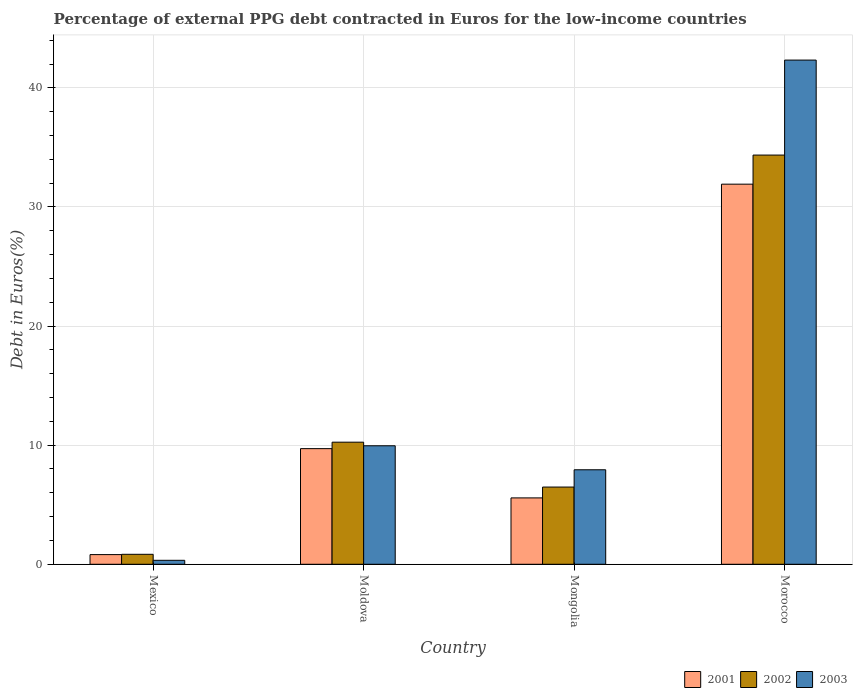How many different coloured bars are there?
Offer a very short reply. 3. Are the number of bars per tick equal to the number of legend labels?
Your answer should be very brief. Yes. How many bars are there on the 4th tick from the right?
Your answer should be very brief. 3. In how many cases, is the number of bars for a given country not equal to the number of legend labels?
Provide a short and direct response. 0. What is the percentage of external PPG debt contracted in Euros in 2002 in Mongolia?
Offer a very short reply. 6.48. Across all countries, what is the maximum percentage of external PPG debt contracted in Euros in 2003?
Provide a short and direct response. 42.33. Across all countries, what is the minimum percentage of external PPG debt contracted in Euros in 2001?
Offer a very short reply. 0.81. In which country was the percentage of external PPG debt contracted in Euros in 2001 maximum?
Offer a very short reply. Morocco. What is the total percentage of external PPG debt contracted in Euros in 2003 in the graph?
Make the answer very short. 60.55. What is the difference between the percentage of external PPG debt contracted in Euros in 2002 in Mexico and that in Mongolia?
Make the answer very short. -5.65. What is the difference between the percentage of external PPG debt contracted in Euros in 2001 in Mexico and the percentage of external PPG debt contracted in Euros in 2002 in Moldova?
Offer a very short reply. -9.44. What is the average percentage of external PPG debt contracted in Euros in 2002 per country?
Provide a short and direct response. 12.98. What is the difference between the percentage of external PPG debt contracted in Euros of/in 2001 and percentage of external PPG debt contracted in Euros of/in 2003 in Moldova?
Give a very brief answer. -0.24. What is the ratio of the percentage of external PPG debt contracted in Euros in 2001 in Mexico to that in Mongolia?
Your response must be concise. 0.15. Is the percentage of external PPG debt contracted in Euros in 2002 in Moldova less than that in Mongolia?
Your answer should be compact. No. Is the difference between the percentage of external PPG debt contracted in Euros in 2001 in Moldova and Mongolia greater than the difference between the percentage of external PPG debt contracted in Euros in 2003 in Moldova and Mongolia?
Your answer should be compact. Yes. What is the difference between the highest and the second highest percentage of external PPG debt contracted in Euros in 2001?
Provide a short and direct response. 4.14. What is the difference between the highest and the lowest percentage of external PPG debt contracted in Euros in 2001?
Give a very brief answer. 31.1. Is the sum of the percentage of external PPG debt contracted in Euros in 2003 in Moldova and Mongolia greater than the maximum percentage of external PPG debt contracted in Euros in 2001 across all countries?
Make the answer very short. No. What does the 2nd bar from the left in Mongolia represents?
Your answer should be very brief. 2002. Is it the case that in every country, the sum of the percentage of external PPG debt contracted in Euros in 2002 and percentage of external PPG debt contracted in Euros in 2003 is greater than the percentage of external PPG debt contracted in Euros in 2001?
Offer a very short reply. Yes. Are all the bars in the graph horizontal?
Give a very brief answer. No. Are the values on the major ticks of Y-axis written in scientific E-notation?
Offer a terse response. No. Does the graph contain any zero values?
Give a very brief answer. No. Does the graph contain grids?
Your answer should be compact. Yes. Where does the legend appear in the graph?
Your answer should be very brief. Bottom right. How many legend labels are there?
Ensure brevity in your answer.  3. What is the title of the graph?
Your answer should be compact. Percentage of external PPG debt contracted in Euros for the low-income countries. Does "1998" appear as one of the legend labels in the graph?
Ensure brevity in your answer.  No. What is the label or title of the Y-axis?
Ensure brevity in your answer.  Debt in Euros(%). What is the Debt in Euros(%) in 2001 in Mexico?
Keep it short and to the point. 0.81. What is the Debt in Euros(%) of 2002 in Mexico?
Keep it short and to the point. 0.84. What is the Debt in Euros(%) in 2003 in Mexico?
Keep it short and to the point. 0.33. What is the Debt in Euros(%) in 2001 in Moldova?
Provide a succinct answer. 9.71. What is the Debt in Euros(%) in 2002 in Moldova?
Offer a very short reply. 10.25. What is the Debt in Euros(%) of 2003 in Moldova?
Provide a short and direct response. 9.95. What is the Debt in Euros(%) of 2001 in Mongolia?
Your response must be concise. 5.57. What is the Debt in Euros(%) of 2002 in Mongolia?
Give a very brief answer. 6.48. What is the Debt in Euros(%) of 2003 in Mongolia?
Your response must be concise. 7.93. What is the Debt in Euros(%) in 2001 in Morocco?
Your answer should be very brief. 31.91. What is the Debt in Euros(%) of 2002 in Morocco?
Make the answer very short. 34.36. What is the Debt in Euros(%) of 2003 in Morocco?
Give a very brief answer. 42.33. Across all countries, what is the maximum Debt in Euros(%) of 2001?
Your answer should be very brief. 31.91. Across all countries, what is the maximum Debt in Euros(%) in 2002?
Your response must be concise. 34.36. Across all countries, what is the maximum Debt in Euros(%) in 2003?
Ensure brevity in your answer.  42.33. Across all countries, what is the minimum Debt in Euros(%) of 2001?
Ensure brevity in your answer.  0.81. Across all countries, what is the minimum Debt in Euros(%) in 2002?
Ensure brevity in your answer.  0.84. Across all countries, what is the minimum Debt in Euros(%) of 2003?
Provide a short and direct response. 0.33. What is the total Debt in Euros(%) in 2001 in the graph?
Ensure brevity in your answer.  48.01. What is the total Debt in Euros(%) of 2002 in the graph?
Your response must be concise. 51.93. What is the total Debt in Euros(%) of 2003 in the graph?
Ensure brevity in your answer.  60.55. What is the difference between the Debt in Euros(%) in 2001 in Mexico and that in Moldova?
Offer a very short reply. -8.9. What is the difference between the Debt in Euros(%) in 2002 in Mexico and that in Moldova?
Your response must be concise. -9.41. What is the difference between the Debt in Euros(%) of 2003 in Mexico and that in Moldova?
Your answer should be compact. -9.62. What is the difference between the Debt in Euros(%) of 2001 in Mexico and that in Mongolia?
Make the answer very short. -4.76. What is the difference between the Debt in Euros(%) of 2002 in Mexico and that in Mongolia?
Offer a terse response. -5.65. What is the difference between the Debt in Euros(%) of 2003 in Mexico and that in Mongolia?
Your answer should be very brief. -7.6. What is the difference between the Debt in Euros(%) in 2001 in Mexico and that in Morocco?
Provide a succinct answer. -31.1. What is the difference between the Debt in Euros(%) in 2002 in Mexico and that in Morocco?
Provide a short and direct response. -33.52. What is the difference between the Debt in Euros(%) in 2003 in Mexico and that in Morocco?
Offer a terse response. -42. What is the difference between the Debt in Euros(%) in 2001 in Moldova and that in Mongolia?
Offer a terse response. 4.14. What is the difference between the Debt in Euros(%) of 2002 in Moldova and that in Mongolia?
Make the answer very short. 3.77. What is the difference between the Debt in Euros(%) of 2003 in Moldova and that in Mongolia?
Make the answer very short. 2.02. What is the difference between the Debt in Euros(%) in 2001 in Moldova and that in Morocco?
Your answer should be compact. -22.2. What is the difference between the Debt in Euros(%) of 2002 in Moldova and that in Morocco?
Offer a very short reply. -24.11. What is the difference between the Debt in Euros(%) in 2003 in Moldova and that in Morocco?
Provide a succinct answer. -32.38. What is the difference between the Debt in Euros(%) of 2001 in Mongolia and that in Morocco?
Make the answer very short. -26.34. What is the difference between the Debt in Euros(%) in 2002 in Mongolia and that in Morocco?
Provide a short and direct response. -27.87. What is the difference between the Debt in Euros(%) of 2003 in Mongolia and that in Morocco?
Give a very brief answer. -34.4. What is the difference between the Debt in Euros(%) in 2001 in Mexico and the Debt in Euros(%) in 2002 in Moldova?
Offer a terse response. -9.44. What is the difference between the Debt in Euros(%) in 2001 in Mexico and the Debt in Euros(%) in 2003 in Moldova?
Provide a succinct answer. -9.14. What is the difference between the Debt in Euros(%) of 2002 in Mexico and the Debt in Euros(%) of 2003 in Moldova?
Your answer should be compact. -9.11. What is the difference between the Debt in Euros(%) in 2001 in Mexico and the Debt in Euros(%) in 2002 in Mongolia?
Offer a terse response. -5.67. What is the difference between the Debt in Euros(%) of 2001 in Mexico and the Debt in Euros(%) of 2003 in Mongolia?
Provide a short and direct response. -7.12. What is the difference between the Debt in Euros(%) of 2002 in Mexico and the Debt in Euros(%) of 2003 in Mongolia?
Provide a succinct answer. -7.1. What is the difference between the Debt in Euros(%) in 2001 in Mexico and the Debt in Euros(%) in 2002 in Morocco?
Offer a very short reply. -33.54. What is the difference between the Debt in Euros(%) in 2001 in Mexico and the Debt in Euros(%) in 2003 in Morocco?
Your answer should be compact. -41.52. What is the difference between the Debt in Euros(%) in 2002 in Mexico and the Debt in Euros(%) in 2003 in Morocco?
Your response must be concise. -41.49. What is the difference between the Debt in Euros(%) of 2001 in Moldova and the Debt in Euros(%) of 2002 in Mongolia?
Your answer should be very brief. 3.23. What is the difference between the Debt in Euros(%) in 2001 in Moldova and the Debt in Euros(%) in 2003 in Mongolia?
Your answer should be compact. 1.77. What is the difference between the Debt in Euros(%) of 2002 in Moldova and the Debt in Euros(%) of 2003 in Mongolia?
Ensure brevity in your answer.  2.32. What is the difference between the Debt in Euros(%) in 2001 in Moldova and the Debt in Euros(%) in 2002 in Morocco?
Your answer should be compact. -24.65. What is the difference between the Debt in Euros(%) in 2001 in Moldova and the Debt in Euros(%) in 2003 in Morocco?
Make the answer very short. -32.62. What is the difference between the Debt in Euros(%) of 2002 in Moldova and the Debt in Euros(%) of 2003 in Morocco?
Your response must be concise. -32.08. What is the difference between the Debt in Euros(%) of 2001 in Mongolia and the Debt in Euros(%) of 2002 in Morocco?
Provide a short and direct response. -28.78. What is the difference between the Debt in Euros(%) of 2001 in Mongolia and the Debt in Euros(%) of 2003 in Morocco?
Provide a short and direct response. -36.76. What is the difference between the Debt in Euros(%) of 2002 in Mongolia and the Debt in Euros(%) of 2003 in Morocco?
Keep it short and to the point. -35.85. What is the average Debt in Euros(%) of 2001 per country?
Offer a terse response. 12. What is the average Debt in Euros(%) of 2002 per country?
Your response must be concise. 12.98. What is the average Debt in Euros(%) of 2003 per country?
Make the answer very short. 15.14. What is the difference between the Debt in Euros(%) in 2001 and Debt in Euros(%) in 2002 in Mexico?
Provide a succinct answer. -0.03. What is the difference between the Debt in Euros(%) of 2001 and Debt in Euros(%) of 2003 in Mexico?
Keep it short and to the point. 0.48. What is the difference between the Debt in Euros(%) in 2002 and Debt in Euros(%) in 2003 in Mexico?
Your response must be concise. 0.5. What is the difference between the Debt in Euros(%) of 2001 and Debt in Euros(%) of 2002 in Moldova?
Your answer should be compact. -0.54. What is the difference between the Debt in Euros(%) in 2001 and Debt in Euros(%) in 2003 in Moldova?
Provide a succinct answer. -0.24. What is the difference between the Debt in Euros(%) in 2002 and Debt in Euros(%) in 2003 in Moldova?
Offer a terse response. 0.3. What is the difference between the Debt in Euros(%) in 2001 and Debt in Euros(%) in 2002 in Mongolia?
Keep it short and to the point. -0.91. What is the difference between the Debt in Euros(%) of 2001 and Debt in Euros(%) of 2003 in Mongolia?
Keep it short and to the point. -2.36. What is the difference between the Debt in Euros(%) in 2002 and Debt in Euros(%) in 2003 in Mongolia?
Provide a short and direct response. -1.45. What is the difference between the Debt in Euros(%) of 2001 and Debt in Euros(%) of 2002 in Morocco?
Provide a short and direct response. -2.44. What is the difference between the Debt in Euros(%) of 2001 and Debt in Euros(%) of 2003 in Morocco?
Your response must be concise. -10.42. What is the difference between the Debt in Euros(%) in 2002 and Debt in Euros(%) in 2003 in Morocco?
Give a very brief answer. -7.98. What is the ratio of the Debt in Euros(%) in 2001 in Mexico to that in Moldova?
Provide a short and direct response. 0.08. What is the ratio of the Debt in Euros(%) in 2002 in Mexico to that in Moldova?
Ensure brevity in your answer.  0.08. What is the ratio of the Debt in Euros(%) of 2003 in Mexico to that in Moldova?
Your response must be concise. 0.03. What is the ratio of the Debt in Euros(%) of 2001 in Mexico to that in Mongolia?
Your response must be concise. 0.15. What is the ratio of the Debt in Euros(%) in 2002 in Mexico to that in Mongolia?
Your answer should be compact. 0.13. What is the ratio of the Debt in Euros(%) in 2003 in Mexico to that in Mongolia?
Ensure brevity in your answer.  0.04. What is the ratio of the Debt in Euros(%) in 2001 in Mexico to that in Morocco?
Provide a succinct answer. 0.03. What is the ratio of the Debt in Euros(%) in 2002 in Mexico to that in Morocco?
Your response must be concise. 0.02. What is the ratio of the Debt in Euros(%) of 2003 in Mexico to that in Morocco?
Make the answer very short. 0.01. What is the ratio of the Debt in Euros(%) of 2001 in Moldova to that in Mongolia?
Provide a succinct answer. 1.74. What is the ratio of the Debt in Euros(%) in 2002 in Moldova to that in Mongolia?
Offer a very short reply. 1.58. What is the ratio of the Debt in Euros(%) of 2003 in Moldova to that in Mongolia?
Keep it short and to the point. 1.25. What is the ratio of the Debt in Euros(%) in 2001 in Moldova to that in Morocco?
Your answer should be very brief. 0.3. What is the ratio of the Debt in Euros(%) of 2002 in Moldova to that in Morocco?
Ensure brevity in your answer.  0.3. What is the ratio of the Debt in Euros(%) in 2003 in Moldova to that in Morocco?
Provide a short and direct response. 0.24. What is the ratio of the Debt in Euros(%) of 2001 in Mongolia to that in Morocco?
Provide a short and direct response. 0.17. What is the ratio of the Debt in Euros(%) in 2002 in Mongolia to that in Morocco?
Provide a succinct answer. 0.19. What is the ratio of the Debt in Euros(%) of 2003 in Mongolia to that in Morocco?
Ensure brevity in your answer.  0.19. What is the difference between the highest and the second highest Debt in Euros(%) of 2001?
Make the answer very short. 22.2. What is the difference between the highest and the second highest Debt in Euros(%) in 2002?
Give a very brief answer. 24.11. What is the difference between the highest and the second highest Debt in Euros(%) in 2003?
Give a very brief answer. 32.38. What is the difference between the highest and the lowest Debt in Euros(%) of 2001?
Offer a terse response. 31.1. What is the difference between the highest and the lowest Debt in Euros(%) in 2002?
Provide a succinct answer. 33.52. What is the difference between the highest and the lowest Debt in Euros(%) of 2003?
Your answer should be compact. 42. 